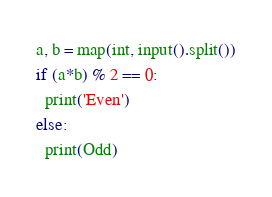<code> <loc_0><loc_0><loc_500><loc_500><_Python_>a, b = map(int, input().split())
if (a*b) % 2 == 0:
  print('Even')
else:
  print(Odd)</code> 